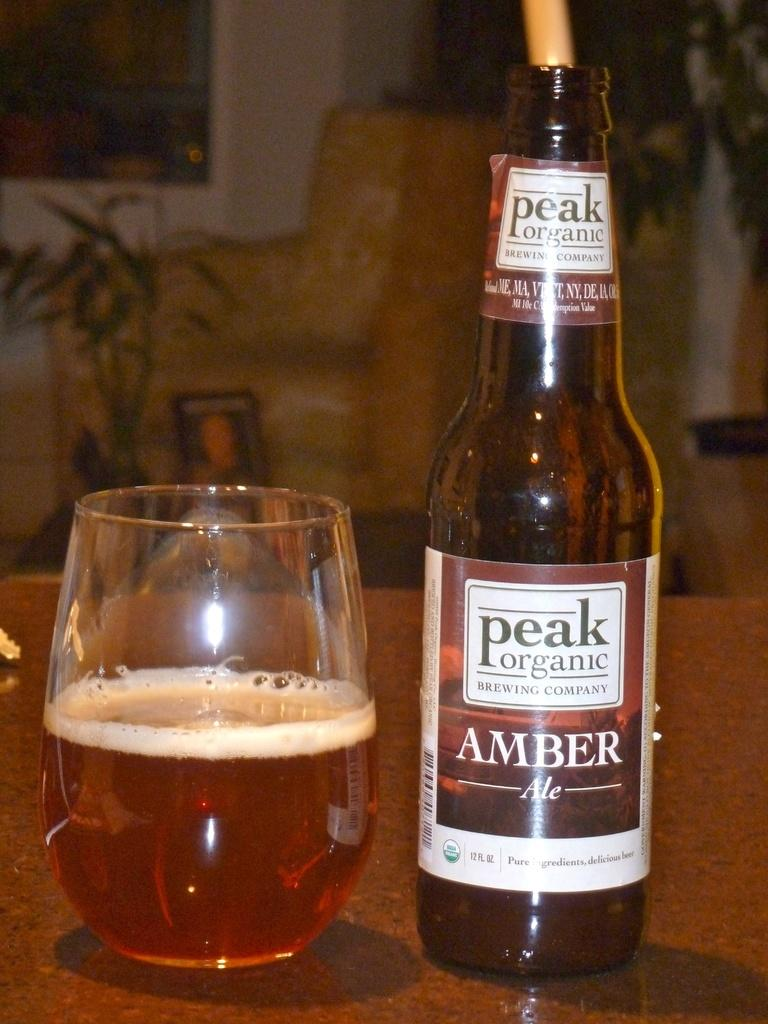What is located at the bottom of the image? There is a table at the bottom of the image. What items can be seen on the table? A bottle and a wine glass are placed on the table. What can be seen in the background of the image? There is a chair, plants, and a wall in the background of the image. What type of verse can be heard being recited in the image? There is no indication in the image that a verse is being recited, so it cannot be determined from the picture. 